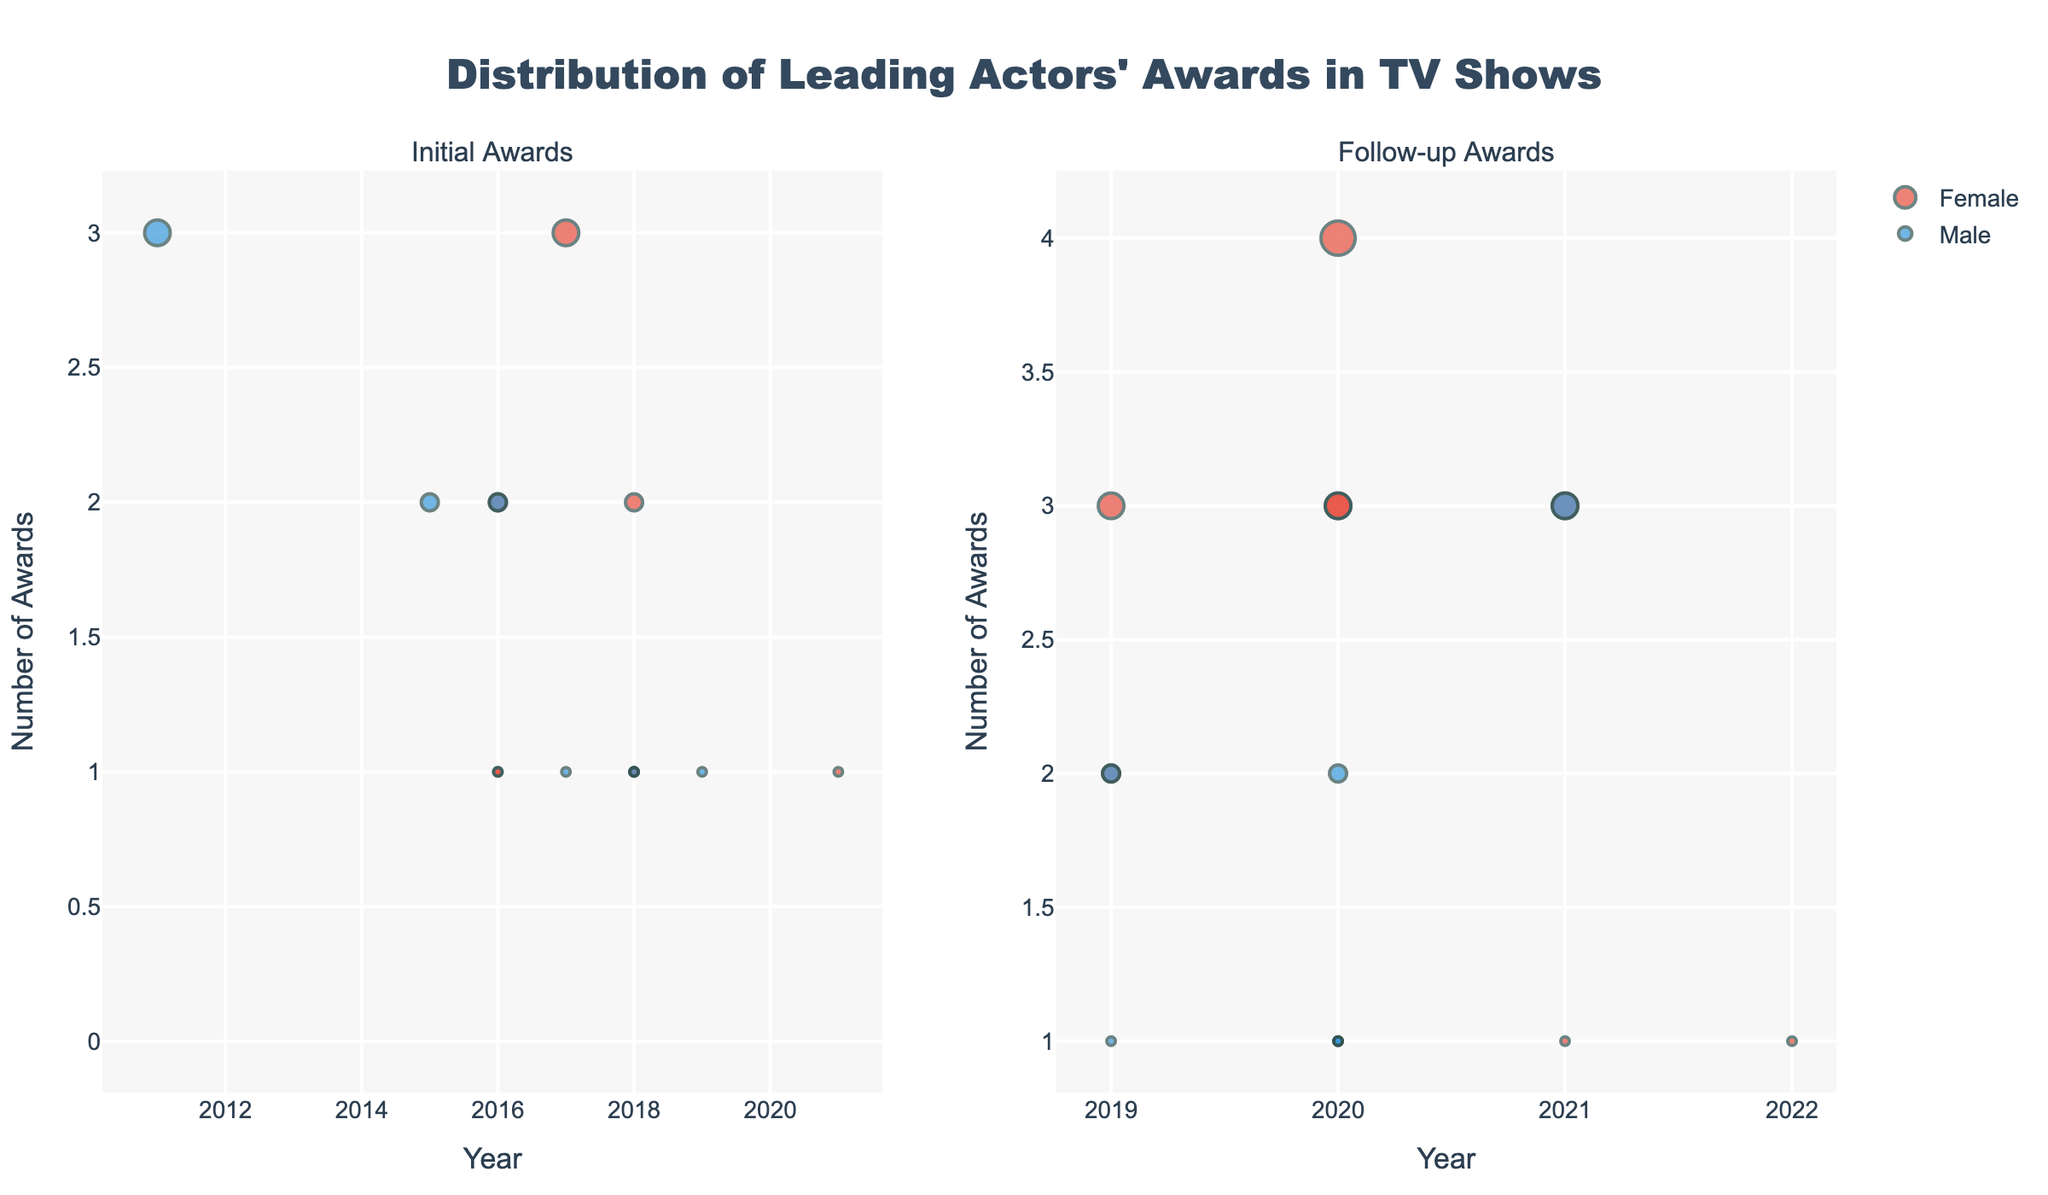What is the title of the figure? The title is displayed at the top of the figure.
Answer: Distribution of Leading Actors' Awards in TV Shows What do the colors represent? The colors are used to differentiate between genders, where blue represents male actors and red represents female actors.
Answer: Genders How many female actors have their follow-up awards listed for the year 2020? Look at the scatter plot for follow-up awards and count the red-colored markers with the x-value of 2020.
Answer: 4 What can you say about the actor with the most initial awards in 2017? Find the marker for the year 2017 with the highest y-value in the initial awards plot and refer to its text label.
Answer: Elisabeth Moss, 3 awards Among the male actors, who had the highest number of follow-up awards and how many were they? Identify the tallest blue marker in the follow-up awards plot and check the label for the actor's name and the y-value for the number of awards.
Answer: Jeremy Strong, 3 How does the distribution of initial awards for male and female actors compare in the year 2016? Compare the number and height of markers for both genders in 2016 in the initial awards plot.
Answer: Female: 2 markers, 1 and 2 awards; Male: 1 marker, 2 awards Which actor had the most growth in the number of awards between initial and follow-up years? Calculate the difference between follow-up and initial awards for each actor and identify the one with the highest increase.
Answer: Olivia Colman, 3 What is the trend in awards for female actors from 2016 to 2021? Observe the plot for female actor markers over the years for both initial and follow-up awards to see if there's an increasing or decreasing trend.
Answer: Increasing trend Who is the only actor to receive 0 initial awards but some follow-up awards? Identify any marker at the y-value of 0 in the initial awards and cross-reference it with data in the follow-up awards.
Answer: Bob Odenkirk How does the average number of follow-up awards for female actors compare to male actors? Sum the follow-up awards for each gender and divide by their respective counts, then compare both averages.
Answer: Female: 2.14, Male: 1.67 